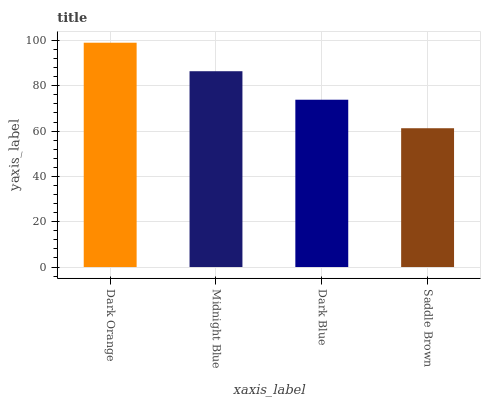Is Midnight Blue the minimum?
Answer yes or no. No. Is Midnight Blue the maximum?
Answer yes or no. No. Is Dark Orange greater than Midnight Blue?
Answer yes or no. Yes. Is Midnight Blue less than Dark Orange?
Answer yes or no. Yes. Is Midnight Blue greater than Dark Orange?
Answer yes or no. No. Is Dark Orange less than Midnight Blue?
Answer yes or no. No. Is Midnight Blue the high median?
Answer yes or no. Yes. Is Dark Blue the low median?
Answer yes or no. Yes. Is Saddle Brown the high median?
Answer yes or no. No. Is Saddle Brown the low median?
Answer yes or no. No. 